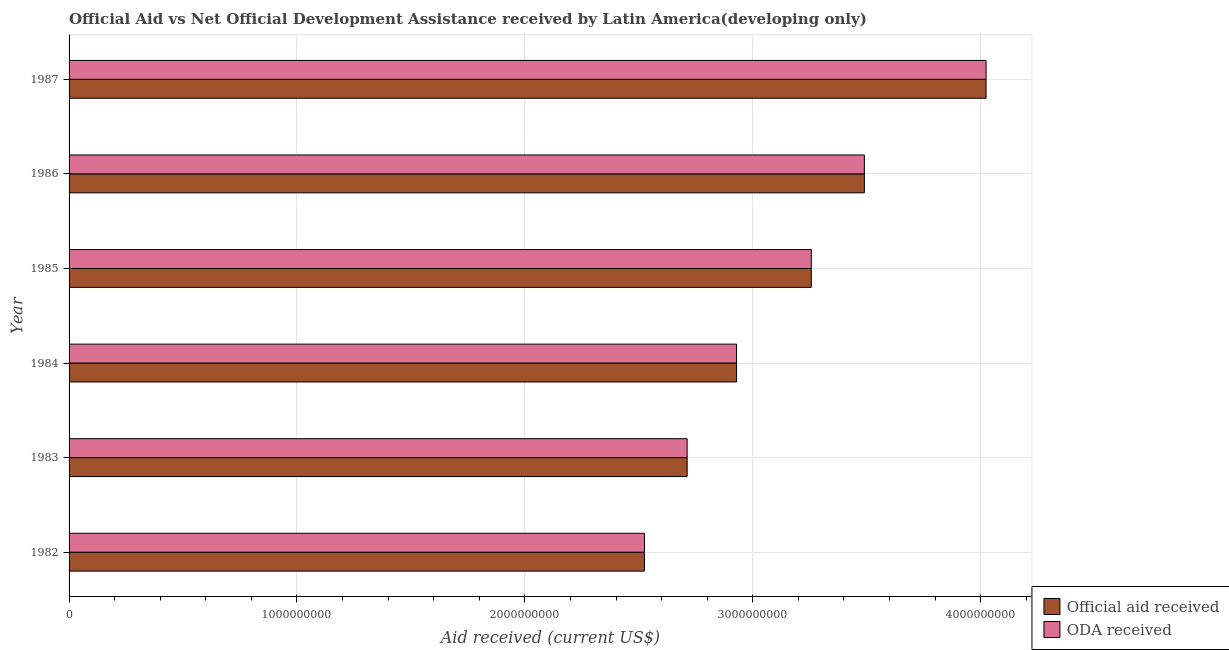Are the number of bars per tick equal to the number of legend labels?
Offer a very short reply. Yes. Are the number of bars on each tick of the Y-axis equal?
Your answer should be compact. Yes. In how many cases, is the number of bars for a given year not equal to the number of legend labels?
Keep it short and to the point. 0. What is the oda received in 1986?
Offer a very short reply. 3.49e+09. Across all years, what is the maximum oda received?
Your answer should be compact. 4.02e+09. Across all years, what is the minimum official aid received?
Your response must be concise. 2.52e+09. What is the total oda received in the graph?
Provide a succinct answer. 1.89e+1. What is the difference between the official aid received in 1983 and that in 1985?
Make the answer very short. -5.45e+08. What is the difference between the oda received in 1985 and the official aid received in 1986?
Offer a very short reply. -2.33e+08. What is the average official aid received per year?
Your answer should be very brief. 3.16e+09. What is the ratio of the oda received in 1982 to that in 1984?
Offer a terse response. 0.86. What is the difference between the highest and the second highest oda received?
Offer a very short reply. 5.34e+08. What is the difference between the highest and the lowest official aid received?
Your answer should be very brief. 1.50e+09. In how many years, is the oda received greater than the average oda received taken over all years?
Provide a short and direct response. 3. What does the 1st bar from the top in 1984 represents?
Provide a short and direct response. ODA received. What does the 2nd bar from the bottom in 1983 represents?
Keep it short and to the point. ODA received. How many bars are there?
Your answer should be very brief. 12. Are all the bars in the graph horizontal?
Your response must be concise. Yes. Are the values on the major ticks of X-axis written in scientific E-notation?
Make the answer very short. No. Does the graph contain any zero values?
Your response must be concise. No. Does the graph contain grids?
Provide a short and direct response. Yes. How many legend labels are there?
Offer a terse response. 2. What is the title of the graph?
Ensure brevity in your answer.  Official Aid vs Net Official Development Assistance received by Latin America(developing only) . What is the label or title of the X-axis?
Make the answer very short. Aid received (current US$). What is the label or title of the Y-axis?
Make the answer very short. Year. What is the Aid received (current US$) of Official aid received in 1982?
Offer a very short reply. 2.52e+09. What is the Aid received (current US$) in ODA received in 1982?
Give a very brief answer. 2.52e+09. What is the Aid received (current US$) in Official aid received in 1983?
Offer a very short reply. 2.71e+09. What is the Aid received (current US$) of ODA received in 1983?
Your response must be concise. 2.71e+09. What is the Aid received (current US$) of Official aid received in 1984?
Your answer should be compact. 2.93e+09. What is the Aid received (current US$) of ODA received in 1984?
Offer a very short reply. 2.93e+09. What is the Aid received (current US$) of Official aid received in 1985?
Ensure brevity in your answer.  3.26e+09. What is the Aid received (current US$) of ODA received in 1985?
Offer a terse response. 3.26e+09. What is the Aid received (current US$) of Official aid received in 1986?
Offer a terse response. 3.49e+09. What is the Aid received (current US$) of ODA received in 1986?
Your answer should be compact. 3.49e+09. What is the Aid received (current US$) in Official aid received in 1987?
Ensure brevity in your answer.  4.02e+09. What is the Aid received (current US$) of ODA received in 1987?
Offer a very short reply. 4.02e+09. Across all years, what is the maximum Aid received (current US$) in Official aid received?
Offer a very short reply. 4.02e+09. Across all years, what is the maximum Aid received (current US$) in ODA received?
Your answer should be compact. 4.02e+09. Across all years, what is the minimum Aid received (current US$) in Official aid received?
Offer a very short reply. 2.52e+09. Across all years, what is the minimum Aid received (current US$) of ODA received?
Give a very brief answer. 2.52e+09. What is the total Aid received (current US$) of Official aid received in the graph?
Keep it short and to the point. 1.89e+1. What is the total Aid received (current US$) in ODA received in the graph?
Give a very brief answer. 1.89e+1. What is the difference between the Aid received (current US$) of Official aid received in 1982 and that in 1983?
Give a very brief answer. -1.87e+08. What is the difference between the Aid received (current US$) of ODA received in 1982 and that in 1983?
Provide a succinct answer. -1.87e+08. What is the difference between the Aid received (current US$) in Official aid received in 1982 and that in 1984?
Your response must be concise. -4.04e+08. What is the difference between the Aid received (current US$) in ODA received in 1982 and that in 1984?
Offer a terse response. -4.04e+08. What is the difference between the Aid received (current US$) of Official aid received in 1982 and that in 1985?
Keep it short and to the point. -7.32e+08. What is the difference between the Aid received (current US$) in ODA received in 1982 and that in 1985?
Ensure brevity in your answer.  -7.32e+08. What is the difference between the Aid received (current US$) in Official aid received in 1982 and that in 1986?
Your answer should be compact. -9.65e+08. What is the difference between the Aid received (current US$) of ODA received in 1982 and that in 1986?
Your answer should be very brief. -9.65e+08. What is the difference between the Aid received (current US$) in Official aid received in 1982 and that in 1987?
Make the answer very short. -1.50e+09. What is the difference between the Aid received (current US$) of ODA received in 1982 and that in 1987?
Your answer should be very brief. -1.50e+09. What is the difference between the Aid received (current US$) in Official aid received in 1983 and that in 1984?
Your response must be concise. -2.17e+08. What is the difference between the Aid received (current US$) in ODA received in 1983 and that in 1984?
Provide a short and direct response. -2.17e+08. What is the difference between the Aid received (current US$) of Official aid received in 1983 and that in 1985?
Your answer should be very brief. -5.45e+08. What is the difference between the Aid received (current US$) of ODA received in 1983 and that in 1985?
Give a very brief answer. -5.45e+08. What is the difference between the Aid received (current US$) of Official aid received in 1983 and that in 1986?
Your answer should be compact. -7.78e+08. What is the difference between the Aid received (current US$) of ODA received in 1983 and that in 1986?
Ensure brevity in your answer.  -7.78e+08. What is the difference between the Aid received (current US$) of Official aid received in 1983 and that in 1987?
Offer a very short reply. -1.31e+09. What is the difference between the Aid received (current US$) of ODA received in 1983 and that in 1987?
Your answer should be very brief. -1.31e+09. What is the difference between the Aid received (current US$) of Official aid received in 1984 and that in 1985?
Give a very brief answer. -3.28e+08. What is the difference between the Aid received (current US$) in ODA received in 1984 and that in 1985?
Offer a terse response. -3.28e+08. What is the difference between the Aid received (current US$) of Official aid received in 1984 and that in 1986?
Your answer should be very brief. -5.61e+08. What is the difference between the Aid received (current US$) of ODA received in 1984 and that in 1986?
Ensure brevity in your answer.  -5.61e+08. What is the difference between the Aid received (current US$) in Official aid received in 1984 and that in 1987?
Make the answer very short. -1.09e+09. What is the difference between the Aid received (current US$) of ODA received in 1984 and that in 1987?
Offer a terse response. -1.09e+09. What is the difference between the Aid received (current US$) of Official aid received in 1985 and that in 1986?
Your answer should be compact. -2.33e+08. What is the difference between the Aid received (current US$) of ODA received in 1985 and that in 1986?
Make the answer very short. -2.33e+08. What is the difference between the Aid received (current US$) in Official aid received in 1985 and that in 1987?
Make the answer very short. -7.67e+08. What is the difference between the Aid received (current US$) in ODA received in 1985 and that in 1987?
Your response must be concise. -7.67e+08. What is the difference between the Aid received (current US$) in Official aid received in 1986 and that in 1987?
Give a very brief answer. -5.34e+08. What is the difference between the Aid received (current US$) of ODA received in 1986 and that in 1987?
Your response must be concise. -5.34e+08. What is the difference between the Aid received (current US$) of Official aid received in 1982 and the Aid received (current US$) of ODA received in 1983?
Provide a short and direct response. -1.87e+08. What is the difference between the Aid received (current US$) of Official aid received in 1982 and the Aid received (current US$) of ODA received in 1984?
Your response must be concise. -4.04e+08. What is the difference between the Aid received (current US$) in Official aid received in 1982 and the Aid received (current US$) in ODA received in 1985?
Make the answer very short. -7.32e+08. What is the difference between the Aid received (current US$) of Official aid received in 1982 and the Aid received (current US$) of ODA received in 1986?
Offer a very short reply. -9.65e+08. What is the difference between the Aid received (current US$) of Official aid received in 1982 and the Aid received (current US$) of ODA received in 1987?
Your answer should be compact. -1.50e+09. What is the difference between the Aid received (current US$) in Official aid received in 1983 and the Aid received (current US$) in ODA received in 1984?
Your response must be concise. -2.17e+08. What is the difference between the Aid received (current US$) of Official aid received in 1983 and the Aid received (current US$) of ODA received in 1985?
Make the answer very short. -5.45e+08. What is the difference between the Aid received (current US$) in Official aid received in 1983 and the Aid received (current US$) in ODA received in 1986?
Give a very brief answer. -7.78e+08. What is the difference between the Aid received (current US$) of Official aid received in 1983 and the Aid received (current US$) of ODA received in 1987?
Provide a short and direct response. -1.31e+09. What is the difference between the Aid received (current US$) in Official aid received in 1984 and the Aid received (current US$) in ODA received in 1985?
Give a very brief answer. -3.28e+08. What is the difference between the Aid received (current US$) of Official aid received in 1984 and the Aid received (current US$) of ODA received in 1986?
Your response must be concise. -5.61e+08. What is the difference between the Aid received (current US$) in Official aid received in 1984 and the Aid received (current US$) in ODA received in 1987?
Give a very brief answer. -1.09e+09. What is the difference between the Aid received (current US$) of Official aid received in 1985 and the Aid received (current US$) of ODA received in 1986?
Make the answer very short. -2.33e+08. What is the difference between the Aid received (current US$) in Official aid received in 1985 and the Aid received (current US$) in ODA received in 1987?
Your answer should be compact. -7.67e+08. What is the difference between the Aid received (current US$) of Official aid received in 1986 and the Aid received (current US$) of ODA received in 1987?
Your response must be concise. -5.34e+08. What is the average Aid received (current US$) in Official aid received per year?
Your answer should be compact. 3.16e+09. What is the average Aid received (current US$) of ODA received per year?
Provide a succinct answer. 3.16e+09. In the year 1983, what is the difference between the Aid received (current US$) in Official aid received and Aid received (current US$) in ODA received?
Provide a succinct answer. 0. In the year 1984, what is the difference between the Aid received (current US$) of Official aid received and Aid received (current US$) of ODA received?
Your answer should be compact. 0. In the year 1985, what is the difference between the Aid received (current US$) of Official aid received and Aid received (current US$) of ODA received?
Ensure brevity in your answer.  0. What is the ratio of the Aid received (current US$) of Official aid received in 1982 to that in 1983?
Offer a very short reply. 0.93. What is the ratio of the Aid received (current US$) in ODA received in 1982 to that in 1983?
Make the answer very short. 0.93. What is the ratio of the Aid received (current US$) in Official aid received in 1982 to that in 1984?
Provide a short and direct response. 0.86. What is the ratio of the Aid received (current US$) of ODA received in 1982 to that in 1984?
Offer a terse response. 0.86. What is the ratio of the Aid received (current US$) in Official aid received in 1982 to that in 1985?
Ensure brevity in your answer.  0.78. What is the ratio of the Aid received (current US$) in ODA received in 1982 to that in 1985?
Your answer should be very brief. 0.78. What is the ratio of the Aid received (current US$) of Official aid received in 1982 to that in 1986?
Offer a very short reply. 0.72. What is the ratio of the Aid received (current US$) in ODA received in 1982 to that in 1986?
Provide a short and direct response. 0.72. What is the ratio of the Aid received (current US$) of Official aid received in 1982 to that in 1987?
Provide a succinct answer. 0.63. What is the ratio of the Aid received (current US$) in ODA received in 1982 to that in 1987?
Your answer should be compact. 0.63. What is the ratio of the Aid received (current US$) of Official aid received in 1983 to that in 1984?
Keep it short and to the point. 0.93. What is the ratio of the Aid received (current US$) in ODA received in 1983 to that in 1984?
Give a very brief answer. 0.93. What is the ratio of the Aid received (current US$) of Official aid received in 1983 to that in 1985?
Provide a short and direct response. 0.83. What is the ratio of the Aid received (current US$) of ODA received in 1983 to that in 1985?
Keep it short and to the point. 0.83. What is the ratio of the Aid received (current US$) of Official aid received in 1983 to that in 1986?
Provide a short and direct response. 0.78. What is the ratio of the Aid received (current US$) in ODA received in 1983 to that in 1986?
Offer a very short reply. 0.78. What is the ratio of the Aid received (current US$) in Official aid received in 1983 to that in 1987?
Make the answer very short. 0.67. What is the ratio of the Aid received (current US$) in ODA received in 1983 to that in 1987?
Ensure brevity in your answer.  0.67. What is the ratio of the Aid received (current US$) of Official aid received in 1984 to that in 1985?
Your answer should be compact. 0.9. What is the ratio of the Aid received (current US$) of ODA received in 1984 to that in 1985?
Your response must be concise. 0.9. What is the ratio of the Aid received (current US$) in Official aid received in 1984 to that in 1986?
Your answer should be very brief. 0.84. What is the ratio of the Aid received (current US$) of ODA received in 1984 to that in 1986?
Provide a short and direct response. 0.84. What is the ratio of the Aid received (current US$) of Official aid received in 1984 to that in 1987?
Offer a terse response. 0.73. What is the ratio of the Aid received (current US$) of ODA received in 1984 to that in 1987?
Provide a short and direct response. 0.73. What is the ratio of the Aid received (current US$) in Official aid received in 1985 to that in 1986?
Keep it short and to the point. 0.93. What is the ratio of the Aid received (current US$) of ODA received in 1985 to that in 1986?
Your answer should be compact. 0.93. What is the ratio of the Aid received (current US$) in Official aid received in 1985 to that in 1987?
Provide a short and direct response. 0.81. What is the ratio of the Aid received (current US$) in ODA received in 1985 to that in 1987?
Your answer should be compact. 0.81. What is the ratio of the Aid received (current US$) of Official aid received in 1986 to that in 1987?
Give a very brief answer. 0.87. What is the ratio of the Aid received (current US$) of ODA received in 1986 to that in 1987?
Provide a succinct answer. 0.87. What is the difference between the highest and the second highest Aid received (current US$) in Official aid received?
Give a very brief answer. 5.34e+08. What is the difference between the highest and the second highest Aid received (current US$) of ODA received?
Give a very brief answer. 5.34e+08. What is the difference between the highest and the lowest Aid received (current US$) in Official aid received?
Ensure brevity in your answer.  1.50e+09. What is the difference between the highest and the lowest Aid received (current US$) in ODA received?
Provide a short and direct response. 1.50e+09. 